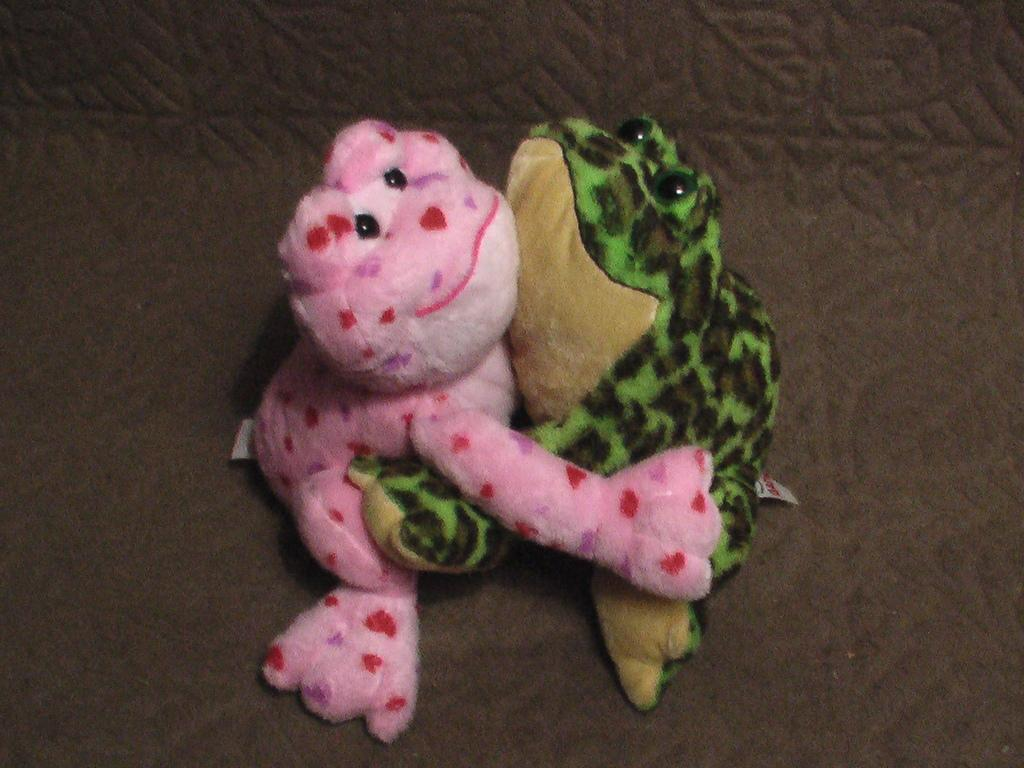What type of objects are in the image? There are two dolls in the image. Can you describe the appearance of the dolls? The dolls are in the shape of frogs. What type of cord is attached to the man in the image? There is no man or cord present in the image; it features two dolls in the shape of frogs. 